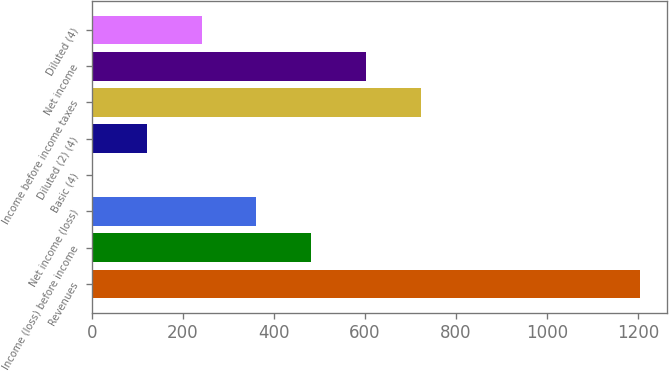<chart> <loc_0><loc_0><loc_500><loc_500><bar_chart><fcel>Revenues<fcel>Income (loss) before income<fcel>Net income (loss)<fcel>Basic (4)<fcel>Diluted (2) (4)<fcel>Income before income taxes<fcel>Net income<fcel>Diluted (4)<nl><fcel>1205<fcel>482.52<fcel>362.1<fcel>0.84<fcel>121.26<fcel>723.36<fcel>602.94<fcel>241.68<nl></chart> 